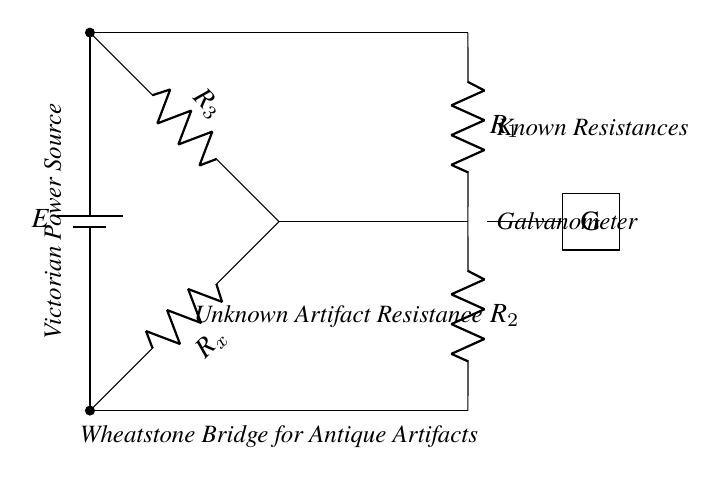What is the type of power source used in this circuit? The circuit features a battery, as indicated by the symbol and label for the power source in the upper left corner of the diagram.
Answer: Battery How many resistors are present in the Wheatstone bridge? There are four resistors labeled R1, R2, R3, and Rx in the diagram, which are clearly indicated at different positions along the bridge circuit.
Answer: Four What does the galvanometer indicate in this circuit? The galvanometer, marked with a G, is used to measure the current flowing through the circuit, which helps determine the balance between the resistances.
Answer: Current What is the purpose of R1 and R2 in this circuit? R1 and R2 are known resistances used for comparison against the unknown resistance Rx, facilitating the measurement process in the Wheatstone bridge setup.
Answer: Comparison If the circuit is balanced, how will the galvanometer respond? In a balanced Wheatstone bridge, the current through the galvanometer will be zero, indicating that the ratio of the resistances R1 to R2 is equal to the ratio of Rx to R3.
Answer: Zero current What happens to the readings when Rx is lower than the ratio of R1 to R2? If Rx is lower than the ratio of R1 to R2, the galvanometer will deflect in one direction, indicating a current flow, which means the bridge is unbalanced.
Answer: Deflects right What aesthetic influence does the circuit exhibit? The circuit's Victorian power source and the ornate representation of components reflect a steampunk aesthetic, merging vintage style with functional technology.
Answer: Steampunk aesthetic 